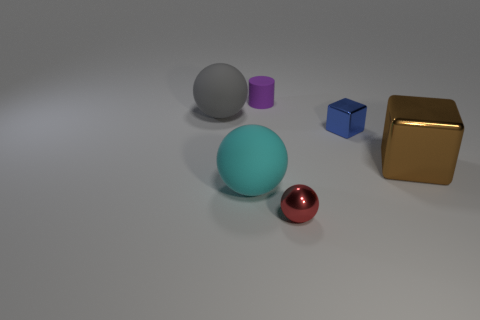Are there more big gray rubber balls in front of the tiny blue metallic object than large gray rubber spheres in front of the metal ball?
Make the answer very short. No. What material is the small thing that is in front of the tiny blue metallic cube?
Your response must be concise. Metal. Is the large cyan thing the same shape as the red metal object?
Offer a terse response. Yes. Is there anything else that is the same color as the large block?
Provide a succinct answer. No. There is another big matte object that is the same shape as the cyan matte thing; what color is it?
Ensure brevity in your answer.  Gray. Are there more brown shiny things behind the cylinder than tiny cylinders?
Provide a short and direct response. No. What is the color of the big rubber thing in front of the gray matte object?
Provide a short and direct response. Cyan. Do the cyan thing and the gray rubber thing have the same size?
Your response must be concise. Yes. The red object has what size?
Your answer should be compact. Small. Is the number of small cyan rubber cubes greater than the number of spheres?
Your response must be concise. No. 